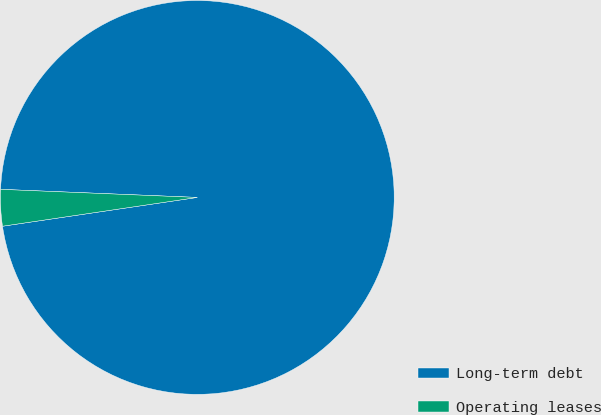Convert chart. <chart><loc_0><loc_0><loc_500><loc_500><pie_chart><fcel>Long-term debt<fcel>Operating leases<nl><fcel>97.01%<fcel>2.99%<nl></chart> 